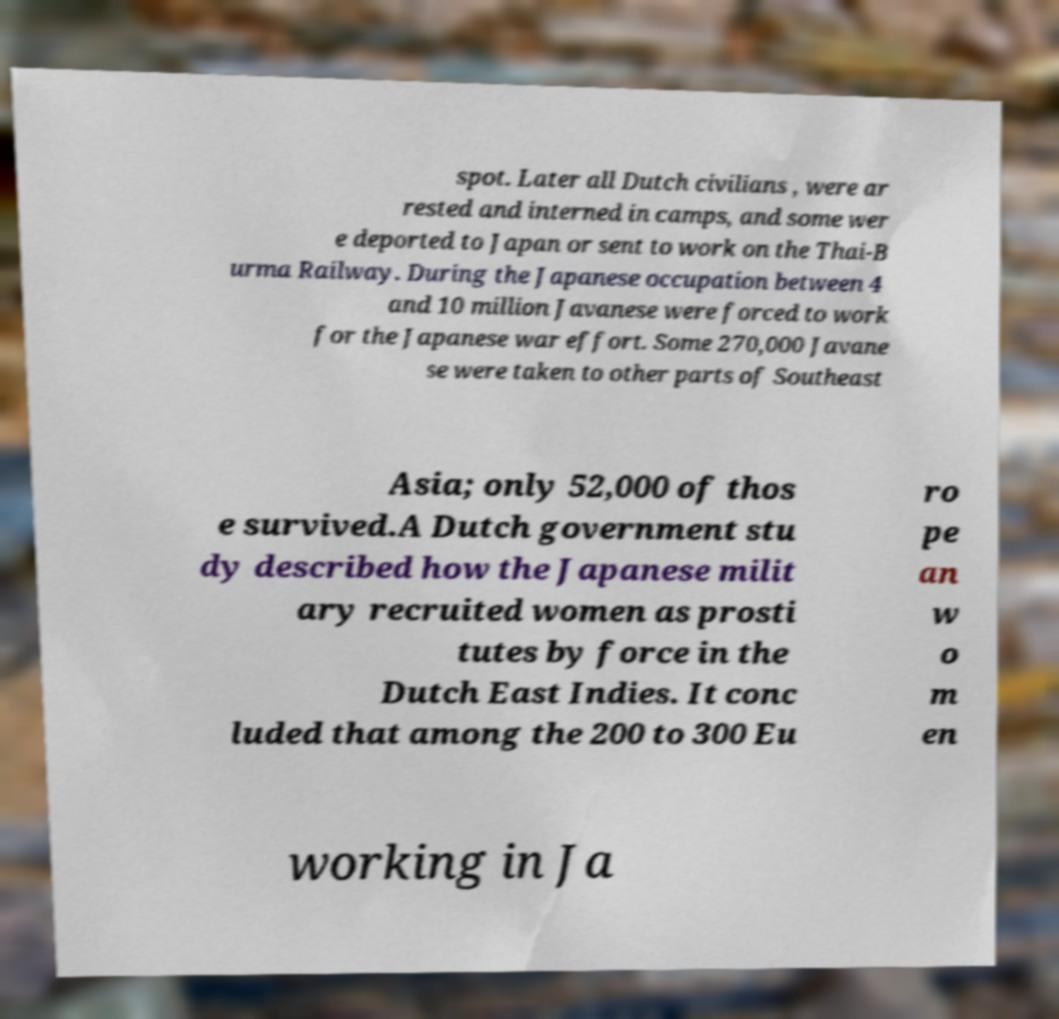For documentation purposes, I need the text within this image transcribed. Could you provide that? spot. Later all Dutch civilians , were ar rested and interned in camps, and some wer e deported to Japan or sent to work on the Thai-B urma Railway. During the Japanese occupation between 4 and 10 million Javanese were forced to work for the Japanese war effort. Some 270,000 Javane se were taken to other parts of Southeast Asia; only 52,000 of thos e survived.A Dutch government stu dy described how the Japanese milit ary recruited women as prosti tutes by force in the Dutch East Indies. It conc luded that among the 200 to 300 Eu ro pe an w o m en working in Ja 